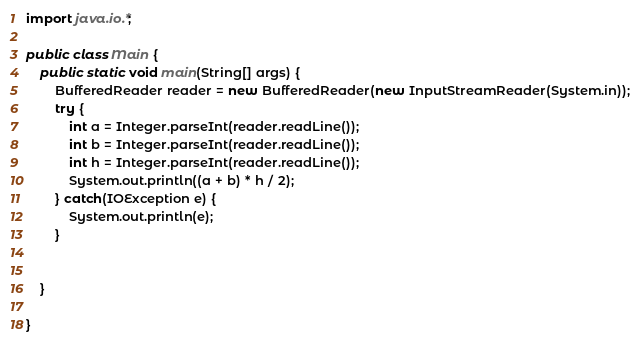<code> <loc_0><loc_0><loc_500><loc_500><_Java_>import java.io.*;

public class Main {
	public static void main(String[] args) {
		BufferedReader reader = new BufferedReader(new InputStreamReader(System.in));
		try {
			int a = Integer.parseInt(reader.readLine());
			int b = Integer.parseInt(reader.readLine());
			int h = Integer.parseInt(reader.readLine());
			System.out.println((a + b) * h / 2);
		} catch(IOException e) {
			System.out.println(e);
		}
		
		
	}

}
</code> 